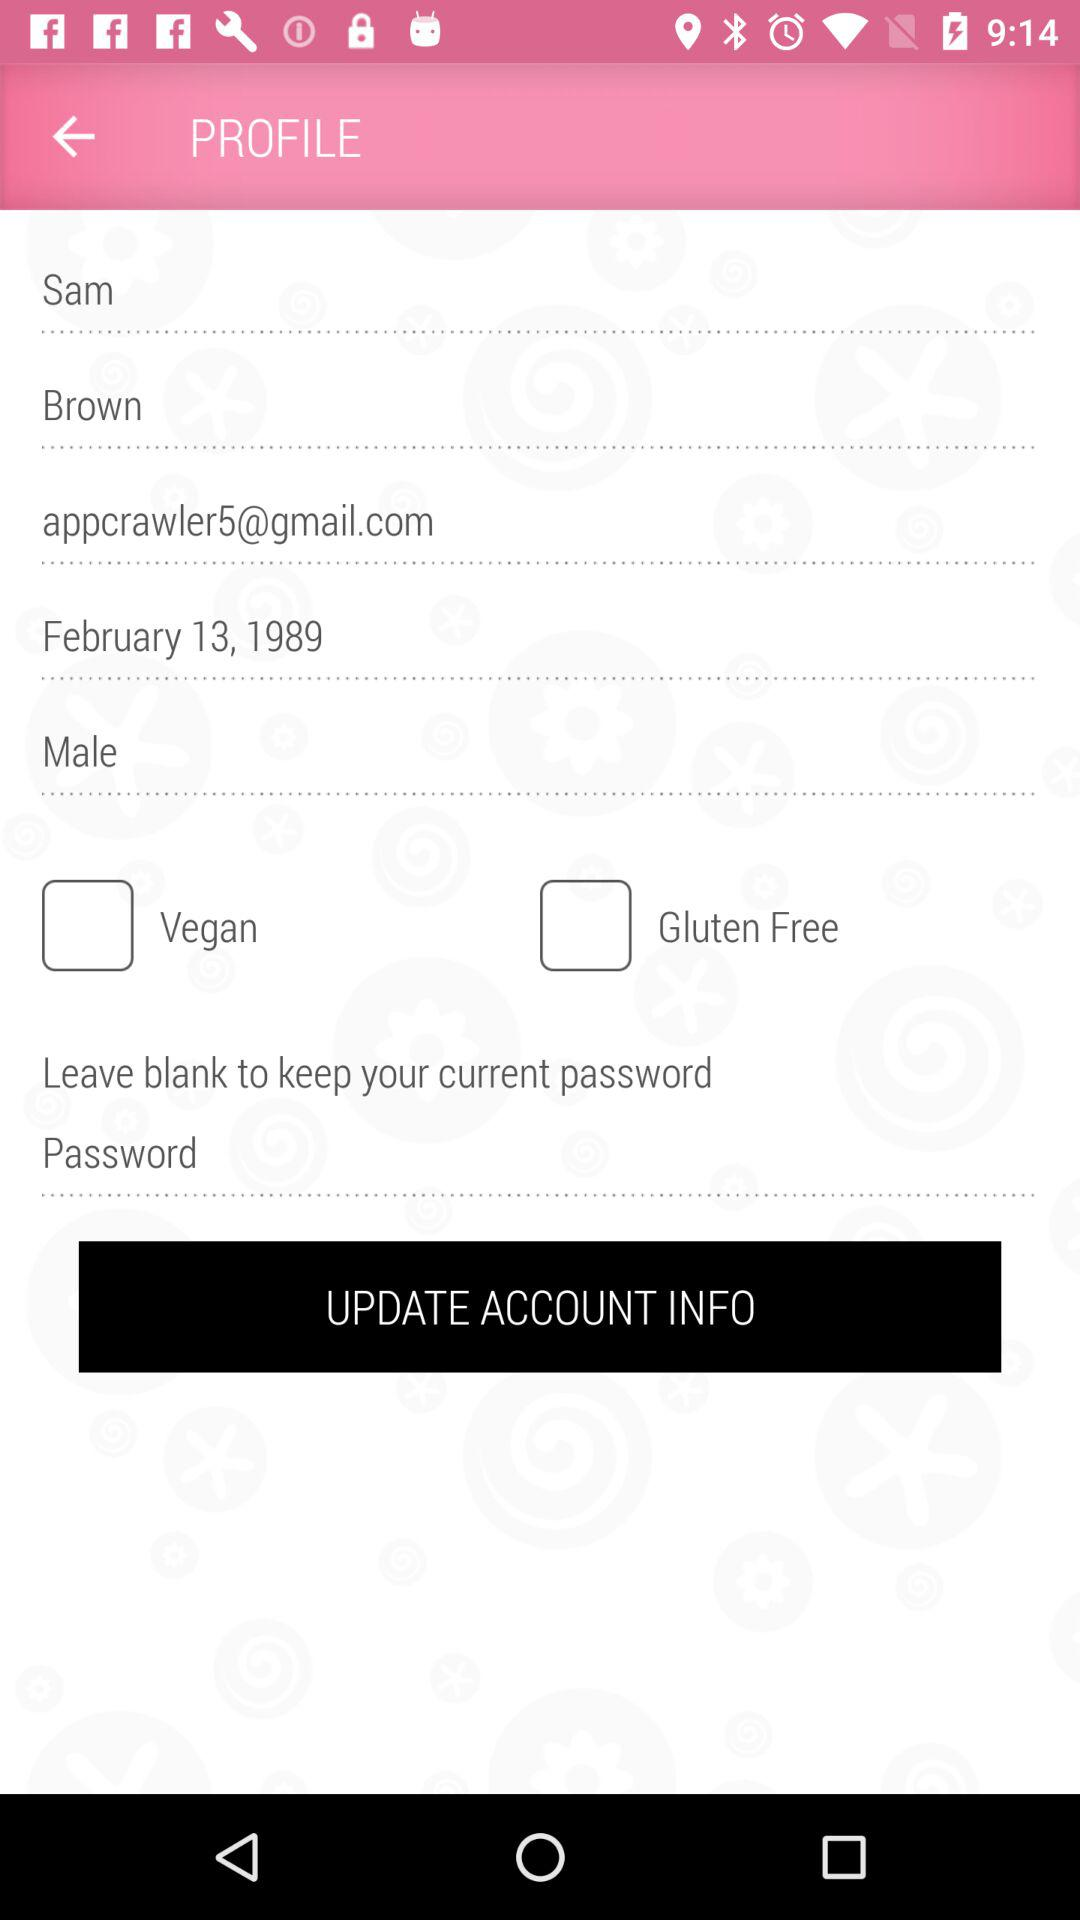What is the name of the user? The name of the user is Sam Brown. 